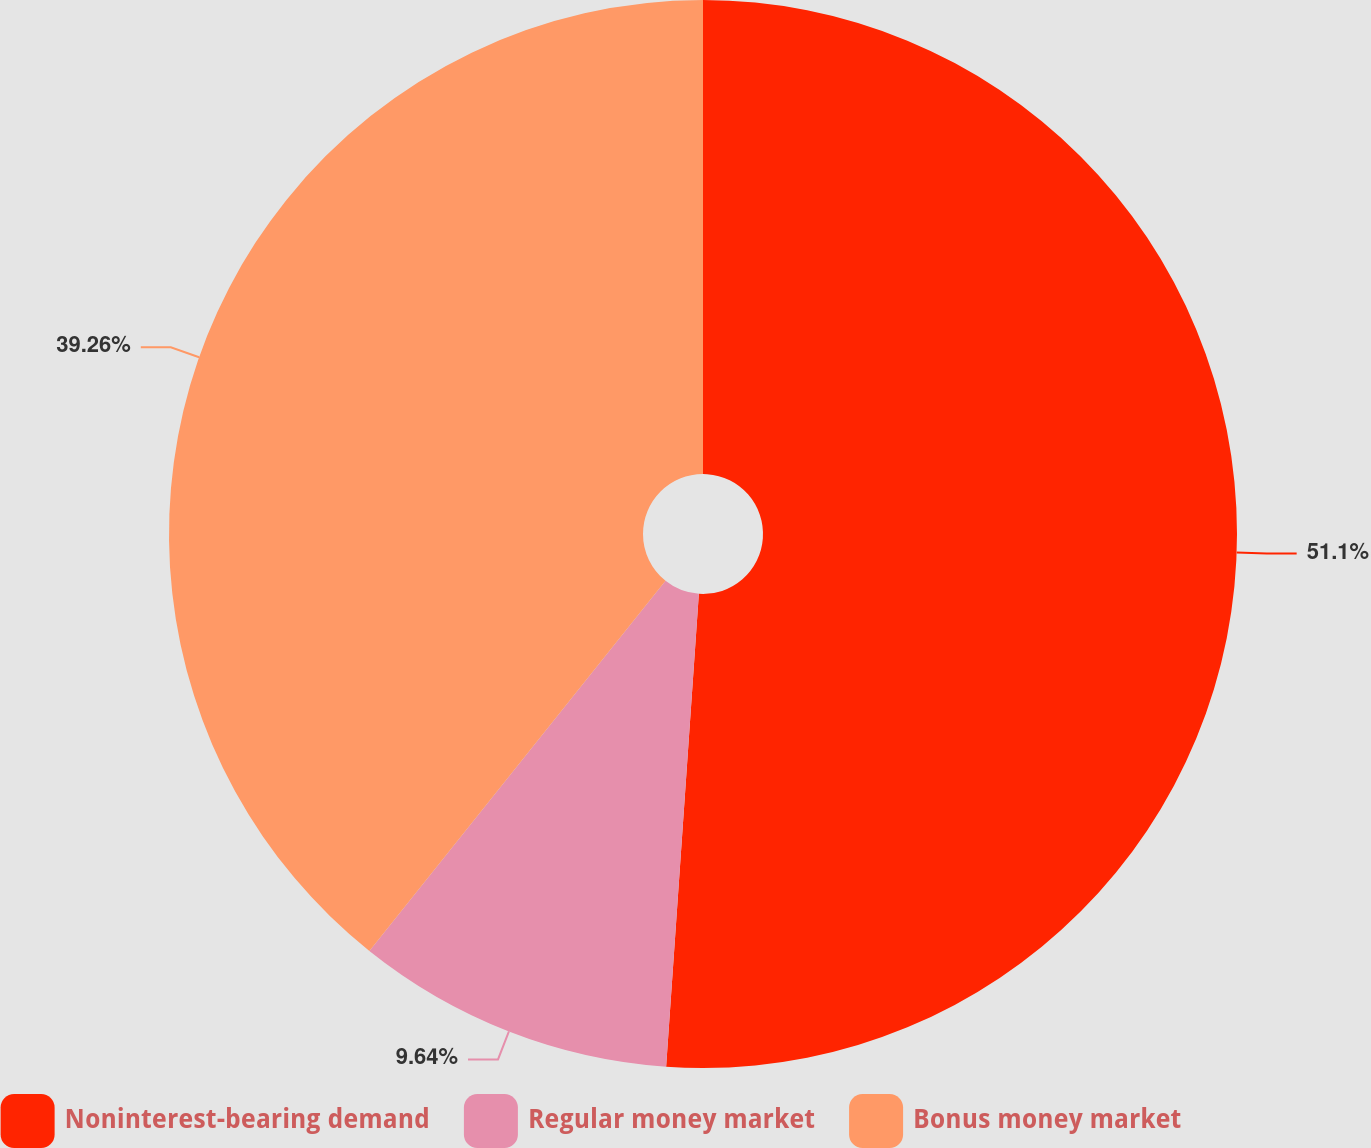<chart> <loc_0><loc_0><loc_500><loc_500><pie_chart><fcel>Noninterest-bearing demand<fcel>Regular money market<fcel>Bonus money market<nl><fcel>51.1%<fcel>9.64%<fcel>39.26%<nl></chart> 